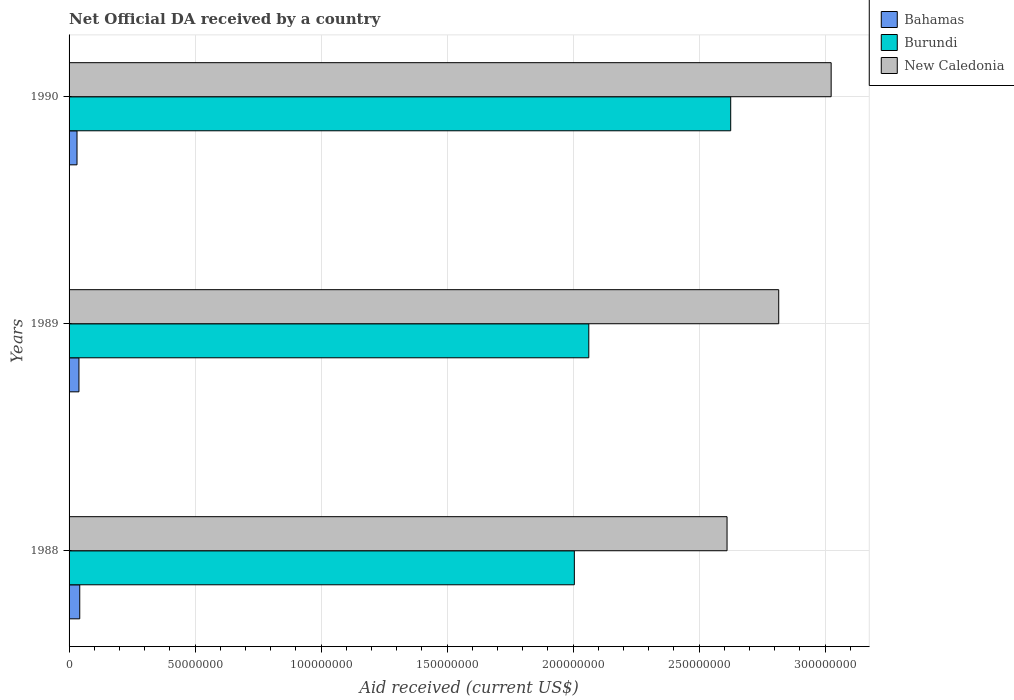How many different coloured bars are there?
Ensure brevity in your answer.  3. How many groups of bars are there?
Your answer should be compact. 3. Are the number of bars on each tick of the Y-axis equal?
Your response must be concise. Yes. What is the label of the 2nd group of bars from the top?
Your answer should be compact. 1989. In how many cases, is the number of bars for a given year not equal to the number of legend labels?
Offer a very short reply. 0. What is the net official development assistance aid received in Bahamas in 1989?
Offer a terse response. 3.92e+06. Across all years, what is the maximum net official development assistance aid received in New Caledonia?
Your response must be concise. 3.02e+08. Across all years, what is the minimum net official development assistance aid received in New Caledonia?
Your answer should be very brief. 2.61e+08. In which year was the net official development assistance aid received in Burundi minimum?
Keep it short and to the point. 1988. What is the total net official development assistance aid received in Burundi in the graph?
Your answer should be compact. 6.69e+08. What is the difference between the net official development assistance aid received in Bahamas in 1989 and that in 1990?
Make the answer very short. 7.70e+05. What is the difference between the net official development assistance aid received in Bahamas in 1988 and the net official development assistance aid received in Burundi in 1989?
Provide a succinct answer. -2.02e+08. What is the average net official development assistance aid received in Bahamas per year?
Offer a terse response. 3.77e+06. In the year 1990, what is the difference between the net official development assistance aid received in New Caledonia and net official development assistance aid received in Burundi?
Provide a short and direct response. 3.99e+07. What is the ratio of the net official development assistance aid received in New Caledonia in 1988 to that in 1990?
Make the answer very short. 0.86. Is the net official development assistance aid received in New Caledonia in 1989 less than that in 1990?
Your answer should be very brief. Yes. Is the difference between the net official development assistance aid received in New Caledonia in 1988 and 1990 greater than the difference between the net official development assistance aid received in Burundi in 1988 and 1990?
Your response must be concise. Yes. What is the difference between the highest and the second highest net official development assistance aid received in New Caledonia?
Keep it short and to the point. 2.08e+07. What is the difference between the highest and the lowest net official development assistance aid received in Burundi?
Provide a short and direct response. 6.20e+07. In how many years, is the net official development assistance aid received in New Caledonia greater than the average net official development assistance aid received in New Caledonia taken over all years?
Give a very brief answer. 1. Is the sum of the net official development assistance aid received in New Caledonia in 1988 and 1990 greater than the maximum net official development assistance aid received in Bahamas across all years?
Give a very brief answer. Yes. What does the 1st bar from the top in 1990 represents?
Ensure brevity in your answer.  New Caledonia. What does the 3rd bar from the bottom in 1990 represents?
Keep it short and to the point. New Caledonia. Is it the case that in every year, the sum of the net official development assistance aid received in New Caledonia and net official development assistance aid received in Bahamas is greater than the net official development assistance aid received in Burundi?
Make the answer very short. Yes. What is the difference between two consecutive major ticks on the X-axis?
Provide a short and direct response. 5.00e+07. Does the graph contain grids?
Your response must be concise. Yes. Where does the legend appear in the graph?
Provide a succinct answer. Top right. How many legend labels are there?
Your answer should be very brief. 3. What is the title of the graph?
Your answer should be very brief. Net Official DA received by a country. Does "Middle East & North Africa (developing only)" appear as one of the legend labels in the graph?
Provide a succinct answer. No. What is the label or title of the X-axis?
Give a very brief answer. Aid received (current US$). What is the label or title of the Y-axis?
Your answer should be very brief. Years. What is the Aid received (current US$) of Bahamas in 1988?
Offer a terse response. 4.24e+06. What is the Aid received (current US$) in Burundi in 1988?
Your answer should be compact. 2.00e+08. What is the Aid received (current US$) of New Caledonia in 1988?
Ensure brevity in your answer.  2.61e+08. What is the Aid received (current US$) of Bahamas in 1989?
Your answer should be very brief. 3.92e+06. What is the Aid received (current US$) of Burundi in 1989?
Offer a terse response. 2.06e+08. What is the Aid received (current US$) in New Caledonia in 1989?
Offer a terse response. 2.82e+08. What is the Aid received (current US$) of Bahamas in 1990?
Your answer should be compact. 3.15e+06. What is the Aid received (current US$) in Burundi in 1990?
Make the answer very short. 2.63e+08. What is the Aid received (current US$) in New Caledonia in 1990?
Your answer should be very brief. 3.02e+08. Across all years, what is the maximum Aid received (current US$) of Bahamas?
Ensure brevity in your answer.  4.24e+06. Across all years, what is the maximum Aid received (current US$) in Burundi?
Your answer should be compact. 2.63e+08. Across all years, what is the maximum Aid received (current US$) in New Caledonia?
Give a very brief answer. 3.02e+08. Across all years, what is the minimum Aid received (current US$) in Bahamas?
Give a very brief answer. 3.15e+06. Across all years, what is the minimum Aid received (current US$) in Burundi?
Provide a succinct answer. 2.00e+08. Across all years, what is the minimum Aid received (current US$) in New Caledonia?
Make the answer very short. 2.61e+08. What is the total Aid received (current US$) of Bahamas in the graph?
Give a very brief answer. 1.13e+07. What is the total Aid received (current US$) in Burundi in the graph?
Ensure brevity in your answer.  6.69e+08. What is the total Aid received (current US$) of New Caledonia in the graph?
Keep it short and to the point. 8.45e+08. What is the difference between the Aid received (current US$) in Bahamas in 1988 and that in 1989?
Provide a succinct answer. 3.20e+05. What is the difference between the Aid received (current US$) of Burundi in 1988 and that in 1989?
Your answer should be very brief. -5.74e+06. What is the difference between the Aid received (current US$) of New Caledonia in 1988 and that in 1989?
Offer a terse response. -2.05e+07. What is the difference between the Aid received (current US$) of Bahamas in 1988 and that in 1990?
Ensure brevity in your answer.  1.09e+06. What is the difference between the Aid received (current US$) of Burundi in 1988 and that in 1990?
Your response must be concise. -6.20e+07. What is the difference between the Aid received (current US$) in New Caledonia in 1988 and that in 1990?
Your response must be concise. -4.13e+07. What is the difference between the Aid received (current US$) of Bahamas in 1989 and that in 1990?
Provide a short and direct response. 7.70e+05. What is the difference between the Aid received (current US$) of Burundi in 1989 and that in 1990?
Make the answer very short. -5.63e+07. What is the difference between the Aid received (current US$) of New Caledonia in 1989 and that in 1990?
Your response must be concise. -2.08e+07. What is the difference between the Aid received (current US$) in Bahamas in 1988 and the Aid received (current US$) in Burundi in 1989?
Provide a short and direct response. -2.02e+08. What is the difference between the Aid received (current US$) in Bahamas in 1988 and the Aid received (current US$) in New Caledonia in 1989?
Ensure brevity in your answer.  -2.77e+08. What is the difference between the Aid received (current US$) of Burundi in 1988 and the Aid received (current US$) of New Caledonia in 1989?
Give a very brief answer. -8.11e+07. What is the difference between the Aid received (current US$) of Bahamas in 1988 and the Aid received (current US$) of Burundi in 1990?
Offer a very short reply. -2.58e+08. What is the difference between the Aid received (current US$) in Bahamas in 1988 and the Aid received (current US$) in New Caledonia in 1990?
Your response must be concise. -2.98e+08. What is the difference between the Aid received (current US$) of Burundi in 1988 and the Aid received (current US$) of New Caledonia in 1990?
Provide a succinct answer. -1.02e+08. What is the difference between the Aid received (current US$) of Bahamas in 1989 and the Aid received (current US$) of Burundi in 1990?
Make the answer very short. -2.59e+08. What is the difference between the Aid received (current US$) in Bahamas in 1989 and the Aid received (current US$) in New Caledonia in 1990?
Provide a succinct answer. -2.98e+08. What is the difference between the Aid received (current US$) of Burundi in 1989 and the Aid received (current US$) of New Caledonia in 1990?
Your answer should be compact. -9.62e+07. What is the average Aid received (current US$) of Bahamas per year?
Your answer should be compact. 3.77e+06. What is the average Aid received (current US$) of Burundi per year?
Your response must be concise. 2.23e+08. What is the average Aid received (current US$) in New Caledonia per year?
Provide a succinct answer. 2.82e+08. In the year 1988, what is the difference between the Aid received (current US$) of Bahamas and Aid received (current US$) of Burundi?
Keep it short and to the point. -1.96e+08. In the year 1988, what is the difference between the Aid received (current US$) of Bahamas and Aid received (current US$) of New Caledonia?
Make the answer very short. -2.57e+08. In the year 1988, what is the difference between the Aid received (current US$) in Burundi and Aid received (current US$) in New Caledonia?
Your answer should be compact. -6.06e+07. In the year 1989, what is the difference between the Aid received (current US$) of Bahamas and Aid received (current US$) of Burundi?
Your answer should be very brief. -2.02e+08. In the year 1989, what is the difference between the Aid received (current US$) in Bahamas and Aid received (current US$) in New Caledonia?
Your response must be concise. -2.78e+08. In the year 1989, what is the difference between the Aid received (current US$) of Burundi and Aid received (current US$) of New Caledonia?
Provide a succinct answer. -7.54e+07. In the year 1990, what is the difference between the Aid received (current US$) in Bahamas and Aid received (current US$) in Burundi?
Provide a succinct answer. -2.59e+08. In the year 1990, what is the difference between the Aid received (current US$) in Bahamas and Aid received (current US$) in New Caledonia?
Offer a very short reply. -2.99e+08. In the year 1990, what is the difference between the Aid received (current US$) in Burundi and Aid received (current US$) in New Caledonia?
Your answer should be very brief. -3.99e+07. What is the ratio of the Aid received (current US$) of Bahamas in 1988 to that in 1989?
Provide a short and direct response. 1.08. What is the ratio of the Aid received (current US$) of Burundi in 1988 to that in 1989?
Your response must be concise. 0.97. What is the ratio of the Aid received (current US$) in New Caledonia in 1988 to that in 1989?
Provide a short and direct response. 0.93. What is the ratio of the Aid received (current US$) of Bahamas in 1988 to that in 1990?
Your answer should be very brief. 1.35. What is the ratio of the Aid received (current US$) in Burundi in 1988 to that in 1990?
Your response must be concise. 0.76. What is the ratio of the Aid received (current US$) in New Caledonia in 1988 to that in 1990?
Offer a terse response. 0.86. What is the ratio of the Aid received (current US$) of Bahamas in 1989 to that in 1990?
Give a very brief answer. 1.24. What is the ratio of the Aid received (current US$) of Burundi in 1989 to that in 1990?
Your answer should be compact. 0.79. What is the ratio of the Aid received (current US$) in New Caledonia in 1989 to that in 1990?
Keep it short and to the point. 0.93. What is the difference between the highest and the second highest Aid received (current US$) of Bahamas?
Give a very brief answer. 3.20e+05. What is the difference between the highest and the second highest Aid received (current US$) in Burundi?
Your answer should be very brief. 5.63e+07. What is the difference between the highest and the second highest Aid received (current US$) of New Caledonia?
Provide a succinct answer. 2.08e+07. What is the difference between the highest and the lowest Aid received (current US$) of Bahamas?
Offer a very short reply. 1.09e+06. What is the difference between the highest and the lowest Aid received (current US$) of Burundi?
Provide a succinct answer. 6.20e+07. What is the difference between the highest and the lowest Aid received (current US$) in New Caledonia?
Make the answer very short. 4.13e+07. 